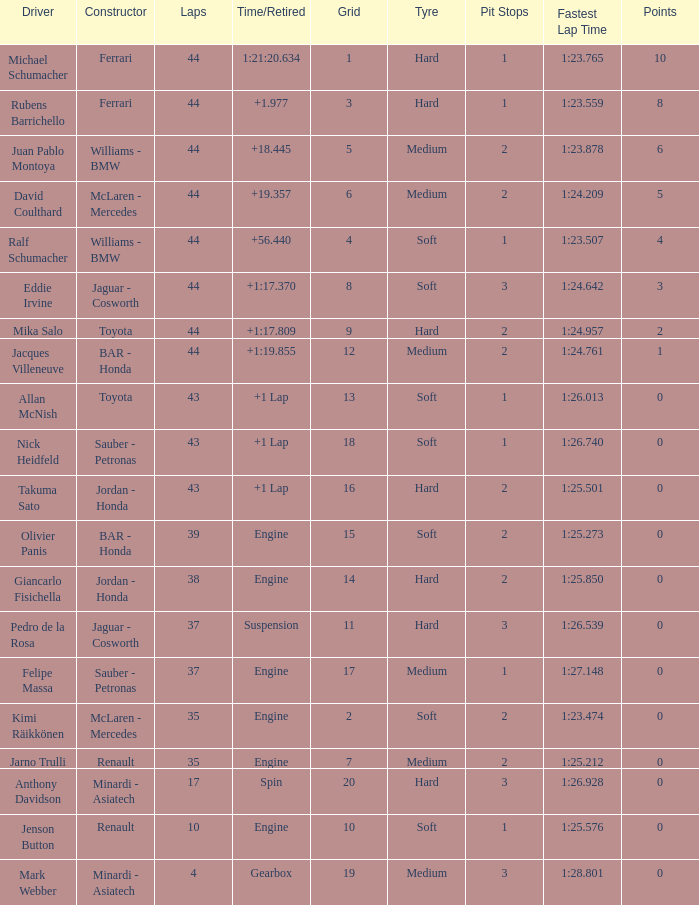What was the time of the driver on grid 3? 1.977. 